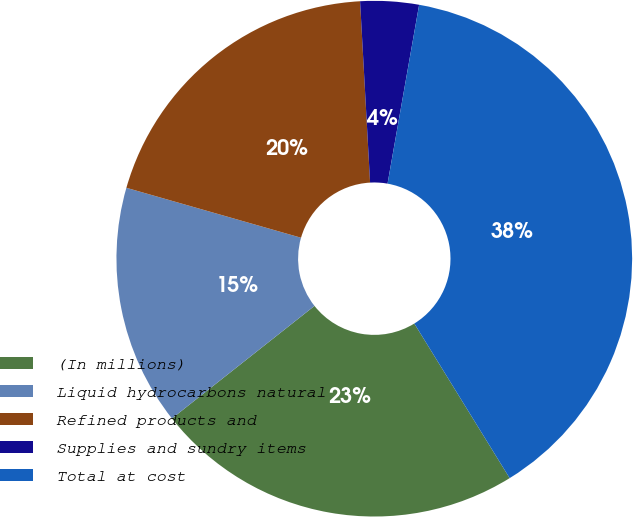Convert chart. <chart><loc_0><loc_0><loc_500><loc_500><pie_chart><fcel>(In millions)<fcel>Liquid hydrocarbons natural<fcel>Refined products and<fcel>Supplies and sundry items<fcel>Total at cost<nl><fcel>23.16%<fcel>15.07%<fcel>19.69%<fcel>3.66%<fcel>38.42%<nl></chart> 